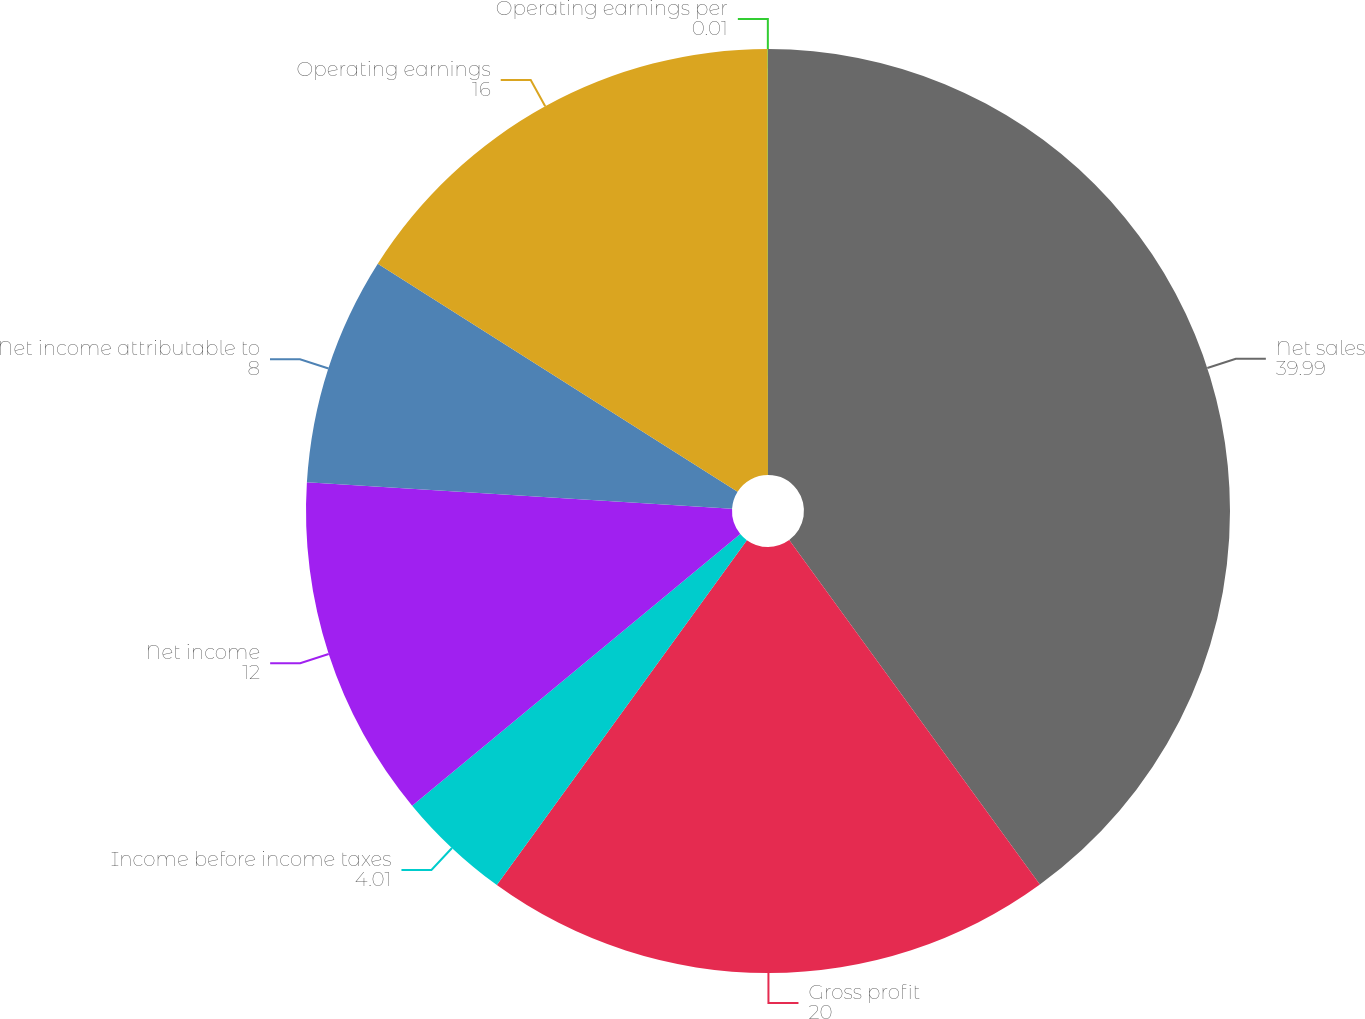<chart> <loc_0><loc_0><loc_500><loc_500><pie_chart><fcel>Net sales<fcel>Gross profit<fcel>Income before income taxes<fcel>Net income<fcel>Net income attributable to<fcel>Operating earnings<fcel>Operating earnings per<nl><fcel>39.99%<fcel>20.0%<fcel>4.01%<fcel>12.0%<fcel>8.0%<fcel>16.0%<fcel>0.01%<nl></chart> 